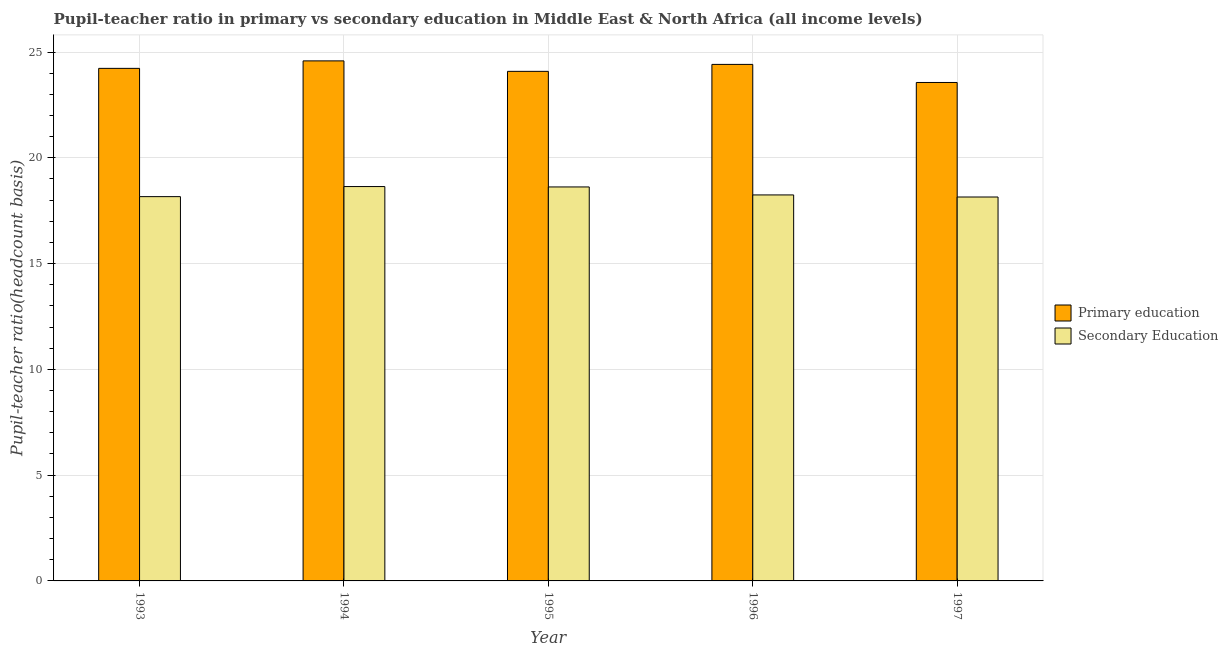Are the number of bars per tick equal to the number of legend labels?
Your response must be concise. Yes. Are the number of bars on each tick of the X-axis equal?
Make the answer very short. Yes. How many bars are there on the 3rd tick from the left?
Offer a very short reply. 2. How many bars are there on the 5th tick from the right?
Keep it short and to the point. 2. What is the pupil teacher ratio on secondary education in 1996?
Offer a very short reply. 18.24. Across all years, what is the maximum pupil-teacher ratio in primary education?
Provide a succinct answer. 24.58. Across all years, what is the minimum pupil-teacher ratio in primary education?
Your response must be concise. 23.56. In which year was the pupil-teacher ratio in primary education minimum?
Provide a short and direct response. 1997. What is the total pupil teacher ratio on secondary education in the graph?
Keep it short and to the point. 91.82. What is the difference between the pupil teacher ratio on secondary education in 1994 and that in 1995?
Your response must be concise. 0.02. What is the difference between the pupil-teacher ratio in primary education in 1995 and the pupil teacher ratio on secondary education in 1994?
Offer a very short reply. -0.49. What is the average pupil-teacher ratio in primary education per year?
Provide a succinct answer. 24.17. In how many years, is the pupil-teacher ratio in primary education greater than 20?
Offer a terse response. 5. What is the ratio of the pupil teacher ratio on secondary education in 1993 to that in 1996?
Keep it short and to the point. 1. Is the difference between the pupil teacher ratio on secondary education in 1995 and 1996 greater than the difference between the pupil-teacher ratio in primary education in 1995 and 1996?
Your answer should be very brief. No. What is the difference between the highest and the second highest pupil teacher ratio on secondary education?
Your response must be concise. 0.02. What is the difference between the highest and the lowest pupil teacher ratio on secondary education?
Ensure brevity in your answer.  0.49. In how many years, is the pupil-teacher ratio in primary education greater than the average pupil-teacher ratio in primary education taken over all years?
Make the answer very short. 3. Is the sum of the pupil-teacher ratio in primary education in 1994 and 1995 greater than the maximum pupil teacher ratio on secondary education across all years?
Offer a very short reply. Yes. What does the 1st bar from the right in 1993 represents?
Keep it short and to the point. Secondary Education. How many bars are there?
Your answer should be compact. 10. Are all the bars in the graph horizontal?
Offer a very short reply. No. How many years are there in the graph?
Make the answer very short. 5. Are the values on the major ticks of Y-axis written in scientific E-notation?
Your answer should be compact. No. Does the graph contain grids?
Offer a very short reply. Yes. How many legend labels are there?
Offer a terse response. 2. How are the legend labels stacked?
Offer a very short reply. Vertical. What is the title of the graph?
Your answer should be compact. Pupil-teacher ratio in primary vs secondary education in Middle East & North Africa (all income levels). Does "Primary school" appear as one of the legend labels in the graph?
Your response must be concise. No. What is the label or title of the X-axis?
Offer a terse response. Year. What is the label or title of the Y-axis?
Your response must be concise. Pupil-teacher ratio(headcount basis). What is the Pupil-teacher ratio(headcount basis) in Primary education in 1993?
Keep it short and to the point. 24.23. What is the Pupil-teacher ratio(headcount basis) in Secondary Education in 1993?
Offer a very short reply. 18.16. What is the Pupil-teacher ratio(headcount basis) in Primary education in 1994?
Give a very brief answer. 24.58. What is the Pupil-teacher ratio(headcount basis) in Secondary Education in 1994?
Offer a terse response. 18.64. What is the Pupil-teacher ratio(headcount basis) of Primary education in 1995?
Your answer should be compact. 24.09. What is the Pupil-teacher ratio(headcount basis) of Secondary Education in 1995?
Give a very brief answer. 18.62. What is the Pupil-teacher ratio(headcount basis) of Primary education in 1996?
Offer a terse response. 24.41. What is the Pupil-teacher ratio(headcount basis) in Secondary Education in 1996?
Make the answer very short. 18.24. What is the Pupil-teacher ratio(headcount basis) of Primary education in 1997?
Offer a very short reply. 23.56. What is the Pupil-teacher ratio(headcount basis) in Secondary Education in 1997?
Ensure brevity in your answer.  18.15. Across all years, what is the maximum Pupil-teacher ratio(headcount basis) of Primary education?
Keep it short and to the point. 24.58. Across all years, what is the maximum Pupil-teacher ratio(headcount basis) of Secondary Education?
Provide a succinct answer. 18.64. Across all years, what is the minimum Pupil-teacher ratio(headcount basis) in Primary education?
Your response must be concise. 23.56. Across all years, what is the minimum Pupil-teacher ratio(headcount basis) of Secondary Education?
Your answer should be very brief. 18.15. What is the total Pupil-teacher ratio(headcount basis) of Primary education in the graph?
Your answer should be compact. 120.87. What is the total Pupil-teacher ratio(headcount basis) in Secondary Education in the graph?
Your answer should be very brief. 91.82. What is the difference between the Pupil-teacher ratio(headcount basis) in Primary education in 1993 and that in 1994?
Give a very brief answer. -0.35. What is the difference between the Pupil-teacher ratio(headcount basis) of Secondary Education in 1993 and that in 1994?
Provide a short and direct response. -0.48. What is the difference between the Pupil-teacher ratio(headcount basis) of Primary education in 1993 and that in 1995?
Your response must be concise. 0.14. What is the difference between the Pupil-teacher ratio(headcount basis) of Secondary Education in 1993 and that in 1995?
Provide a short and direct response. -0.46. What is the difference between the Pupil-teacher ratio(headcount basis) of Primary education in 1993 and that in 1996?
Provide a succinct answer. -0.19. What is the difference between the Pupil-teacher ratio(headcount basis) of Secondary Education in 1993 and that in 1996?
Ensure brevity in your answer.  -0.08. What is the difference between the Pupil-teacher ratio(headcount basis) of Primary education in 1993 and that in 1997?
Offer a very short reply. 0.67. What is the difference between the Pupil-teacher ratio(headcount basis) in Secondary Education in 1993 and that in 1997?
Make the answer very short. 0.02. What is the difference between the Pupil-teacher ratio(headcount basis) of Primary education in 1994 and that in 1995?
Give a very brief answer. 0.49. What is the difference between the Pupil-teacher ratio(headcount basis) in Secondary Education in 1994 and that in 1995?
Provide a short and direct response. 0.02. What is the difference between the Pupil-teacher ratio(headcount basis) of Primary education in 1994 and that in 1996?
Offer a terse response. 0.17. What is the difference between the Pupil-teacher ratio(headcount basis) in Secondary Education in 1994 and that in 1996?
Provide a short and direct response. 0.4. What is the difference between the Pupil-teacher ratio(headcount basis) of Primary education in 1994 and that in 1997?
Keep it short and to the point. 1.02. What is the difference between the Pupil-teacher ratio(headcount basis) in Secondary Education in 1994 and that in 1997?
Provide a short and direct response. 0.49. What is the difference between the Pupil-teacher ratio(headcount basis) in Primary education in 1995 and that in 1996?
Give a very brief answer. -0.33. What is the difference between the Pupil-teacher ratio(headcount basis) of Secondary Education in 1995 and that in 1996?
Keep it short and to the point. 0.38. What is the difference between the Pupil-teacher ratio(headcount basis) in Primary education in 1995 and that in 1997?
Offer a very short reply. 0.53. What is the difference between the Pupil-teacher ratio(headcount basis) of Secondary Education in 1995 and that in 1997?
Your answer should be very brief. 0.48. What is the difference between the Pupil-teacher ratio(headcount basis) of Primary education in 1996 and that in 1997?
Your response must be concise. 0.85. What is the difference between the Pupil-teacher ratio(headcount basis) of Secondary Education in 1996 and that in 1997?
Give a very brief answer. 0.1. What is the difference between the Pupil-teacher ratio(headcount basis) in Primary education in 1993 and the Pupil-teacher ratio(headcount basis) in Secondary Education in 1994?
Ensure brevity in your answer.  5.59. What is the difference between the Pupil-teacher ratio(headcount basis) of Primary education in 1993 and the Pupil-teacher ratio(headcount basis) of Secondary Education in 1995?
Offer a terse response. 5.6. What is the difference between the Pupil-teacher ratio(headcount basis) of Primary education in 1993 and the Pupil-teacher ratio(headcount basis) of Secondary Education in 1996?
Keep it short and to the point. 5.98. What is the difference between the Pupil-teacher ratio(headcount basis) in Primary education in 1993 and the Pupil-teacher ratio(headcount basis) in Secondary Education in 1997?
Ensure brevity in your answer.  6.08. What is the difference between the Pupil-teacher ratio(headcount basis) in Primary education in 1994 and the Pupil-teacher ratio(headcount basis) in Secondary Education in 1995?
Offer a very short reply. 5.96. What is the difference between the Pupil-teacher ratio(headcount basis) of Primary education in 1994 and the Pupil-teacher ratio(headcount basis) of Secondary Education in 1996?
Provide a succinct answer. 6.34. What is the difference between the Pupil-teacher ratio(headcount basis) in Primary education in 1994 and the Pupil-teacher ratio(headcount basis) in Secondary Education in 1997?
Make the answer very short. 6.43. What is the difference between the Pupil-teacher ratio(headcount basis) of Primary education in 1995 and the Pupil-teacher ratio(headcount basis) of Secondary Education in 1996?
Give a very brief answer. 5.84. What is the difference between the Pupil-teacher ratio(headcount basis) of Primary education in 1995 and the Pupil-teacher ratio(headcount basis) of Secondary Education in 1997?
Your answer should be very brief. 5.94. What is the difference between the Pupil-teacher ratio(headcount basis) in Primary education in 1996 and the Pupil-teacher ratio(headcount basis) in Secondary Education in 1997?
Offer a very short reply. 6.27. What is the average Pupil-teacher ratio(headcount basis) of Primary education per year?
Your answer should be compact. 24.17. What is the average Pupil-teacher ratio(headcount basis) in Secondary Education per year?
Your response must be concise. 18.36. In the year 1993, what is the difference between the Pupil-teacher ratio(headcount basis) of Primary education and Pupil-teacher ratio(headcount basis) of Secondary Education?
Keep it short and to the point. 6.06. In the year 1994, what is the difference between the Pupil-teacher ratio(headcount basis) of Primary education and Pupil-teacher ratio(headcount basis) of Secondary Education?
Your answer should be very brief. 5.94. In the year 1995, what is the difference between the Pupil-teacher ratio(headcount basis) of Primary education and Pupil-teacher ratio(headcount basis) of Secondary Education?
Offer a terse response. 5.46. In the year 1996, what is the difference between the Pupil-teacher ratio(headcount basis) in Primary education and Pupil-teacher ratio(headcount basis) in Secondary Education?
Keep it short and to the point. 6.17. In the year 1997, what is the difference between the Pupil-teacher ratio(headcount basis) in Primary education and Pupil-teacher ratio(headcount basis) in Secondary Education?
Provide a succinct answer. 5.41. What is the ratio of the Pupil-teacher ratio(headcount basis) in Primary education in 1993 to that in 1994?
Your answer should be compact. 0.99. What is the ratio of the Pupil-teacher ratio(headcount basis) in Secondary Education in 1993 to that in 1994?
Your answer should be very brief. 0.97. What is the ratio of the Pupil-teacher ratio(headcount basis) of Primary education in 1993 to that in 1995?
Your response must be concise. 1.01. What is the ratio of the Pupil-teacher ratio(headcount basis) of Secondary Education in 1993 to that in 1995?
Provide a short and direct response. 0.98. What is the ratio of the Pupil-teacher ratio(headcount basis) of Primary education in 1993 to that in 1997?
Your response must be concise. 1.03. What is the ratio of the Pupil-teacher ratio(headcount basis) of Secondary Education in 1993 to that in 1997?
Make the answer very short. 1. What is the ratio of the Pupil-teacher ratio(headcount basis) in Primary education in 1994 to that in 1995?
Offer a very short reply. 1.02. What is the ratio of the Pupil-teacher ratio(headcount basis) in Primary education in 1994 to that in 1996?
Ensure brevity in your answer.  1.01. What is the ratio of the Pupil-teacher ratio(headcount basis) of Secondary Education in 1994 to that in 1996?
Offer a very short reply. 1.02. What is the ratio of the Pupil-teacher ratio(headcount basis) of Primary education in 1994 to that in 1997?
Your answer should be compact. 1.04. What is the ratio of the Pupil-teacher ratio(headcount basis) of Secondary Education in 1994 to that in 1997?
Provide a succinct answer. 1.03. What is the ratio of the Pupil-teacher ratio(headcount basis) in Primary education in 1995 to that in 1996?
Provide a short and direct response. 0.99. What is the ratio of the Pupil-teacher ratio(headcount basis) of Secondary Education in 1995 to that in 1996?
Provide a succinct answer. 1.02. What is the ratio of the Pupil-teacher ratio(headcount basis) in Primary education in 1995 to that in 1997?
Give a very brief answer. 1.02. What is the ratio of the Pupil-teacher ratio(headcount basis) in Secondary Education in 1995 to that in 1997?
Give a very brief answer. 1.03. What is the ratio of the Pupil-teacher ratio(headcount basis) of Primary education in 1996 to that in 1997?
Your answer should be compact. 1.04. What is the ratio of the Pupil-teacher ratio(headcount basis) of Secondary Education in 1996 to that in 1997?
Provide a succinct answer. 1.01. What is the difference between the highest and the second highest Pupil-teacher ratio(headcount basis) in Primary education?
Keep it short and to the point. 0.17. What is the difference between the highest and the second highest Pupil-teacher ratio(headcount basis) in Secondary Education?
Your answer should be very brief. 0.02. What is the difference between the highest and the lowest Pupil-teacher ratio(headcount basis) of Primary education?
Make the answer very short. 1.02. What is the difference between the highest and the lowest Pupil-teacher ratio(headcount basis) of Secondary Education?
Offer a very short reply. 0.49. 